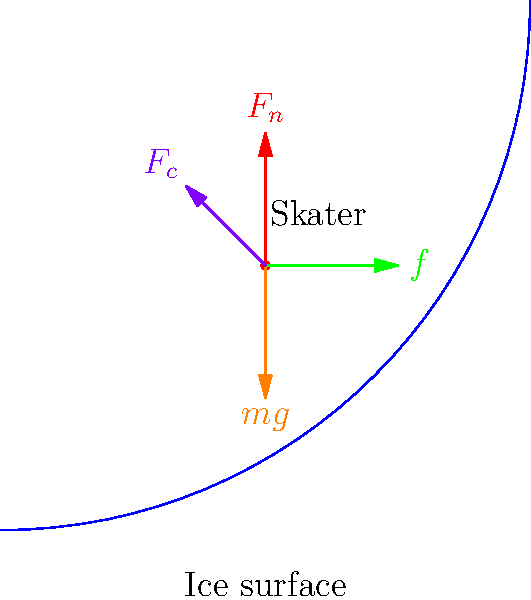In a hydroblading move, a figure skater leans into a deep edge while traveling on a curved path. Using the force diagram provided, calculate the coefficient of friction $\mu$ between the skate blade and the ice if the skater's mass is 50 kg, the radius of curvature is 3 m, and the skater is traveling at 5 m/s. Assume $g = 9.8$ m/s². To solve this problem, we'll follow these steps:

1) Identify the forces acting on the skater:
   - Normal force ($F_n$) perpendicular to the ice surface
   - Friction force ($f$) tangent to the curved path
   - Gravitational force ($mg$) acting downward
   - Centripetal force ($F_c$) acting towards the center of the curve

2) The centripetal force is provided by the horizontal component of the normal force:
   $F_c = F_n \sin \theta = \frac{mv^2}{r}$

3) The vertical component of the normal force balances the gravitational force:
   $F_n \cos \theta = mg$

4) From (2) and (3), we can derive:
   $\tan \theta = \frac{v^2}{rg}$

5) The friction force is related to the normal force by the coefficient of friction:
   $f = \mu F_n$

6) The friction force provides the force needed to move the skater forward, which is equal to the tangential component of the gravitational force:
   $f = mg \sin \theta$

7) Substituting (5) into (6):
   $\mu F_n = mg \sin \theta$

8) Dividing both sides by $F_n \cos \theta$ (which equals $mg$ from step 3):
   $\mu = \tan \theta$

9) From step 4, we know that $\tan \theta = \frac{v^2}{rg}$

10) Now we can substitute the given values:
    $\mu = \frac{v^2}{rg} = \frac{(5 \text{ m/s})^2}{(3 \text{ m})(9.8 \text{ m/s²})} \approx 0.085$

Therefore, the coefficient of friction between the skate blade and the ice is approximately 0.085.
Answer: $\mu \approx 0.085$ 